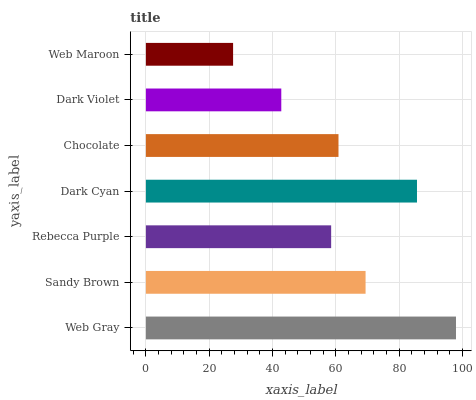Is Web Maroon the minimum?
Answer yes or no. Yes. Is Web Gray the maximum?
Answer yes or no. Yes. Is Sandy Brown the minimum?
Answer yes or no. No. Is Sandy Brown the maximum?
Answer yes or no. No. Is Web Gray greater than Sandy Brown?
Answer yes or no. Yes. Is Sandy Brown less than Web Gray?
Answer yes or no. Yes. Is Sandy Brown greater than Web Gray?
Answer yes or no. No. Is Web Gray less than Sandy Brown?
Answer yes or no. No. Is Chocolate the high median?
Answer yes or no. Yes. Is Chocolate the low median?
Answer yes or no. Yes. Is Dark Violet the high median?
Answer yes or no. No. Is Dark Violet the low median?
Answer yes or no. No. 